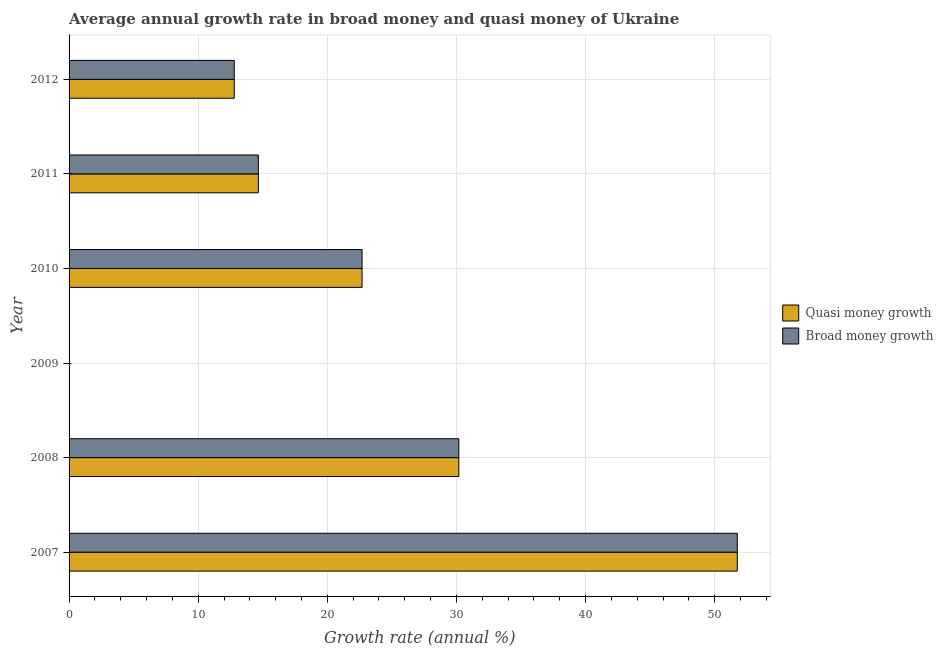How many bars are there on the 1st tick from the top?
Offer a very short reply. 2. How many bars are there on the 6th tick from the bottom?
Your answer should be very brief. 2. What is the label of the 6th group of bars from the top?
Your response must be concise. 2007. In how many cases, is the number of bars for a given year not equal to the number of legend labels?
Offer a terse response. 1. What is the annual growth rate in quasi money in 2011?
Provide a short and direct response. 14.66. Across all years, what is the maximum annual growth rate in quasi money?
Offer a very short reply. 51.75. In which year was the annual growth rate in broad money maximum?
Your answer should be very brief. 2007. What is the total annual growth rate in broad money in the graph?
Offer a very short reply. 132.07. What is the difference between the annual growth rate in broad money in 2008 and that in 2011?
Provide a short and direct response. 15.52. What is the difference between the annual growth rate in quasi money in 2009 and the annual growth rate in broad money in 2010?
Offer a very short reply. -22.69. What is the average annual growth rate in quasi money per year?
Your answer should be compact. 22.01. In the year 2008, what is the difference between the annual growth rate in broad money and annual growth rate in quasi money?
Offer a very short reply. 0. In how many years, is the annual growth rate in broad money greater than 50 %?
Offer a terse response. 1. What is the ratio of the annual growth rate in broad money in 2007 to that in 2011?
Ensure brevity in your answer.  3.53. Is the annual growth rate in quasi money in 2008 less than that in 2010?
Make the answer very short. No. What is the difference between the highest and the second highest annual growth rate in quasi money?
Your answer should be compact. 21.57. What is the difference between the highest and the lowest annual growth rate in broad money?
Offer a terse response. 51.75. In how many years, is the annual growth rate in broad money greater than the average annual growth rate in broad money taken over all years?
Give a very brief answer. 3. What is the difference between two consecutive major ticks on the X-axis?
Make the answer very short. 10. Are the values on the major ticks of X-axis written in scientific E-notation?
Make the answer very short. No. Does the graph contain grids?
Offer a terse response. Yes. How are the legend labels stacked?
Ensure brevity in your answer.  Vertical. What is the title of the graph?
Your answer should be very brief. Average annual growth rate in broad money and quasi money of Ukraine. Does "Urban agglomerations" appear as one of the legend labels in the graph?
Offer a terse response. No. What is the label or title of the X-axis?
Keep it short and to the point. Growth rate (annual %). What is the label or title of the Y-axis?
Your response must be concise. Year. What is the Growth rate (annual %) of Quasi money growth in 2007?
Your answer should be compact. 51.75. What is the Growth rate (annual %) of Broad money growth in 2007?
Keep it short and to the point. 51.75. What is the Growth rate (annual %) in Quasi money growth in 2008?
Your answer should be very brief. 30.18. What is the Growth rate (annual %) of Broad money growth in 2008?
Provide a short and direct response. 30.18. What is the Growth rate (annual %) of Broad money growth in 2009?
Your response must be concise. 0. What is the Growth rate (annual %) in Quasi money growth in 2010?
Offer a terse response. 22.69. What is the Growth rate (annual %) in Broad money growth in 2010?
Provide a short and direct response. 22.69. What is the Growth rate (annual %) of Quasi money growth in 2011?
Provide a succinct answer. 14.66. What is the Growth rate (annual %) of Broad money growth in 2011?
Offer a very short reply. 14.66. What is the Growth rate (annual %) in Quasi money growth in 2012?
Your answer should be compact. 12.79. What is the Growth rate (annual %) of Broad money growth in 2012?
Provide a succinct answer. 12.79. Across all years, what is the maximum Growth rate (annual %) in Quasi money growth?
Your answer should be compact. 51.75. Across all years, what is the maximum Growth rate (annual %) of Broad money growth?
Your response must be concise. 51.75. Across all years, what is the minimum Growth rate (annual %) in Quasi money growth?
Make the answer very short. 0. Across all years, what is the minimum Growth rate (annual %) of Broad money growth?
Your answer should be very brief. 0. What is the total Growth rate (annual %) in Quasi money growth in the graph?
Offer a terse response. 132.07. What is the total Growth rate (annual %) of Broad money growth in the graph?
Offer a terse response. 132.07. What is the difference between the Growth rate (annual %) in Quasi money growth in 2007 and that in 2008?
Make the answer very short. 21.56. What is the difference between the Growth rate (annual %) of Broad money growth in 2007 and that in 2008?
Make the answer very short. 21.56. What is the difference between the Growth rate (annual %) in Quasi money growth in 2007 and that in 2010?
Provide a short and direct response. 29.06. What is the difference between the Growth rate (annual %) of Broad money growth in 2007 and that in 2010?
Give a very brief answer. 29.06. What is the difference between the Growth rate (annual %) in Quasi money growth in 2007 and that in 2011?
Your response must be concise. 37.09. What is the difference between the Growth rate (annual %) in Broad money growth in 2007 and that in 2011?
Make the answer very short. 37.09. What is the difference between the Growth rate (annual %) of Quasi money growth in 2007 and that in 2012?
Provide a succinct answer. 38.96. What is the difference between the Growth rate (annual %) in Broad money growth in 2007 and that in 2012?
Ensure brevity in your answer.  38.96. What is the difference between the Growth rate (annual %) of Quasi money growth in 2008 and that in 2010?
Make the answer very short. 7.49. What is the difference between the Growth rate (annual %) of Broad money growth in 2008 and that in 2010?
Offer a terse response. 7.49. What is the difference between the Growth rate (annual %) of Quasi money growth in 2008 and that in 2011?
Your answer should be compact. 15.52. What is the difference between the Growth rate (annual %) in Broad money growth in 2008 and that in 2011?
Keep it short and to the point. 15.52. What is the difference between the Growth rate (annual %) in Quasi money growth in 2008 and that in 2012?
Offer a terse response. 17.39. What is the difference between the Growth rate (annual %) in Broad money growth in 2008 and that in 2012?
Offer a terse response. 17.39. What is the difference between the Growth rate (annual %) in Quasi money growth in 2010 and that in 2011?
Your answer should be compact. 8.03. What is the difference between the Growth rate (annual %) in Broad money growth in 2010 and that in 2011?
Give a very brief answer. 8.03. What is the difference between the Growth rate (annual %) of Quasi money growth in 2010 and that in 2012?
Your response must be concise. 9.9. What is the difference between the Growth rate (annual %) in Broad money growth in 2010 and that in 2012?
Your answer should be very brief. 9.9. What is the difference between the Growth rate (annual %) of Quasi money growth in 2011 and that in 2012?
Give a very brief answer. 1.87. What is the difference between the Growth rate (annual %) in Broad money growth in 2011 and that in 2012?
Offer a very short reply. 1.87. What is the difference between the Growth rate (annual %) in Quasi money growth in 2007 and the Growth rate (annual %) in Broad money growth in 2008?
Ensure brevity in your answer.  21.56. What is the difference between the Growth rate (annual %) of Quasi money growth in 2007 and the Growth rate (annual %) of Broad money growth in 2010?
Your answer should be compact. 29.06. What is the difference between the Growth rate (annual %) of Quasi money growth in 2007 and the Growth rate (annual %) of Broad money growth in 2011?
Keep it short and to the point. 37.09. What is the difference between the Growth rate (annual %) of Quasi money growth in 2007 and the Growth rate (annual %) of Broad money growth in 2012?
Your answer should be compact. 38.96. What is the difference between the Growth rate (annual %) of Quasi money growth in 2008 and the Growth rate (annual %) of Broad money growth in 2010?
Provide a succinct answer. 7.49. What is the difference between the Growth rate (annual %) in Quasi money growth in 2008 and the Growth rate (annual %) in Broad money growth in 2011?
Your answer should be very brief. 15.52. What is the difference between the Growth rate (annual %) in Quasi money growth in 2008 and the Growth rate (annual %) in Broad money growth in 2012?
Provide a succinct answer. 17.39. What is the difference between the Growth rate (annual %) of Quasi money growth in 2010 and the Growth rate (annual %) of Broad money growth in 2011?
Keep it short and to the point. 8.03. What is the difference between the Growth rate (annual %) of Quasi money growth in 2010 and the Growth rate (annual %) of Broad money growth in 2012?
Offer a terse response. 9.9. What is the difference between the Growth rate (annual %) of Quasi money growth in 2011 and the Growth rate (annual %) of Broad money growth in 2012?
Your response must be concise. 1.87. What is the average Growth rate (annual %) in Quasi money growth per year?
Your response must be concise. 22.01. What is the average Growth rate (annual %) of Broad money growth per year?
Provide a short and direct response. 22.01. In the year 2007, what is the difference between the Growth rate (annual %) in Quasi money growth and Growth rate (annual %) in Broad money growth?
Provide a short and direct response. 0. In the year 2008, what is the difference between the Growth rate (annual %) of Quasi money growth and Growth rate (annual %) of Broad money growth?
Provide a succinct answer. 0. In the year 2012, what is the difference between the Growth rate (annual %) of Quasi money growth and Growth rate (annual %) of Broad money growth?
Keep it short and to the point. 0. What is the ratio of the Growth rate (annual %) of Quasi money growth in 2007 to that in 2008?
Ensure brevity in your answer.  1.71. What is the ratio of the Growth rate (annual %) in Broad money growth in 2007 to that in 2008?
Provide a short and direct response. 1.71. What is the ratio of the Growth rate (annual %) in Quasi money growth in 2007 to that in 2010?
Your answer should be compact. 2.28. What is the ratio of the Growth rate (annual %) in Broad money growth in 2007 to that in 2010?
Offer a very short reply. 2.28. What is the ratio of the Growth rate (annual %) of Quasi money growth in 2007 to that in 2011?
Keep it short and to the point. 3.53. What is the ratio of the Growth rate (annual %) in Broad money growth in 2007 to that in 2011?
Provide a succinct answer. 3.53. What is the ratio of the Growth rate (annual %) of Quasi money growth in 2007 to that in 2012?
Offer a terse response. 4.05. What is the ratio of the Growth rate (annual %) of Broad money growth in 2007 to that in 2012?
Ensure brevity in your answer.  4.05. What is the ratio of the Growth rate (annual %) of Quasi money growth in 2008 to that in 2010?
Ensure brevity in your answer.  1.33. What is the ratio of the Growth rate (annual %) in Broad money growth in 2008 to that in 2010?
Offer a very short reply. 1.33. What is the ratio of the Growth rate (annual %) of Quasi money growth in 2008 to that in 2011?
Provide a succinct answer. 2.06. What is the ratio of the Growth rate (annual %) of Broad money growth in 2008 to that in 2011?
Offer a terse response. 2.06. What is the ratio of the Growth rate (annual %) in Quasi money growth in 2008 to that in 2012?
Provide a succinct answer. 2.36. What is the ratio of the Growth rate (annual %) in Broad money growth in 2008 to that in 2012?
Provide a short and direct response. 2.36. What is the ratio of the Growth rate (annual %) of Quasi money growth in 2010 to that in 2011?
Offer a terse response. 1.55. What is the ratio of the Growth rate (annual %) of Broad money growth in 2010 to that in 2011?
Keep it short and to the point. 1.55. What is the ratio of the Growth rate (annual %) of Quasi money growth in 2010 to that in 2012?
Provide a succinct answer. 1.77. What is the ratio of the Growth rate (annual %) of Broad money growth in 2010 to that in 2012?
Ensure brevity in your answer.  1.77. What is the ratio of the Growth rate (annual %) in Quasi money growth in 2011 to that in 2012?
Your response must be concise. 1.15. What is the ratio of the Growth rate (annual %) of Broad money growth in 2011 to that in 2012?
Keep it short and to the point. 1.15. What is the difference between the highest and the second highest Growth rate (annual %) of Quasi money growth?
Provide a short and direct response. 21.56. What is the difference between the highest and the second highest Growth rate (annual %) in Broad money growth?
Give a very brief answer. 21.56. What is the difference between the highest and the lowest Growth rate (annual %) in Quasi money growth?
Your response must be concise. 51.75. What is the difference between the highest and the lowest Growth rate (annual %) in Broad money growth?
Your answer should be very brief. 51.75. 